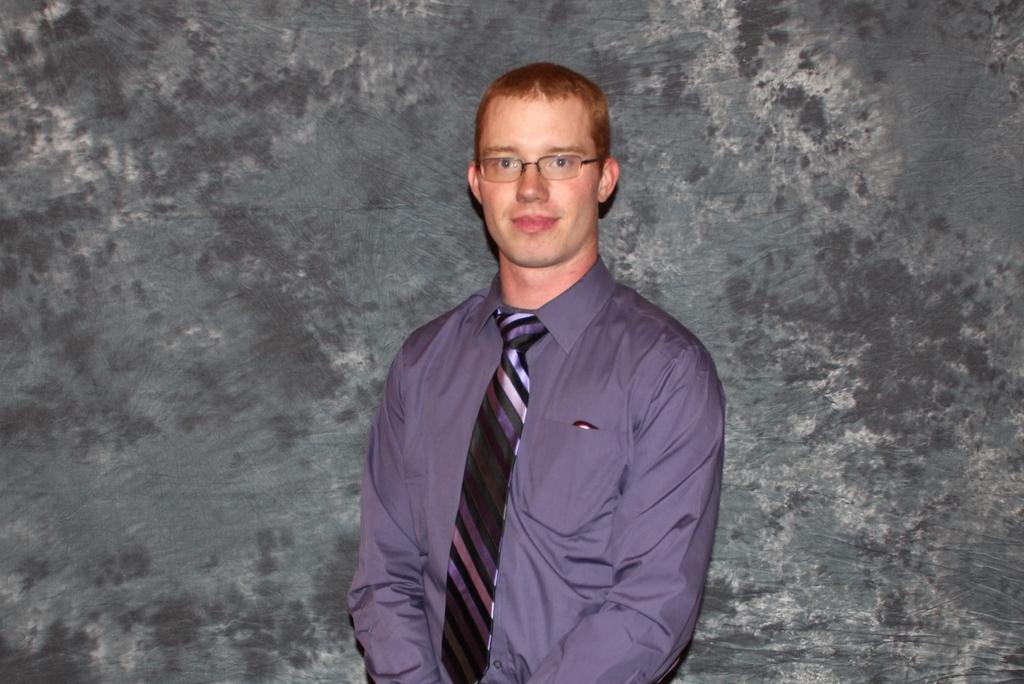What is the main subject of the image? The main subject of the image is a man. What is the man wearing in the image? The man is wearing a t-shirt and a tie. What is the man doing in the image? The man is standing, smiling, and giving a pose for the picture. What can be seen in the background of the image? There is a wall in the background of the image. What type of cable can be seen in the image? There is no cable present in the image. What kind of band is playing in the background of the image? There is no band present in the image; it only features a man standing in front of a wall. 